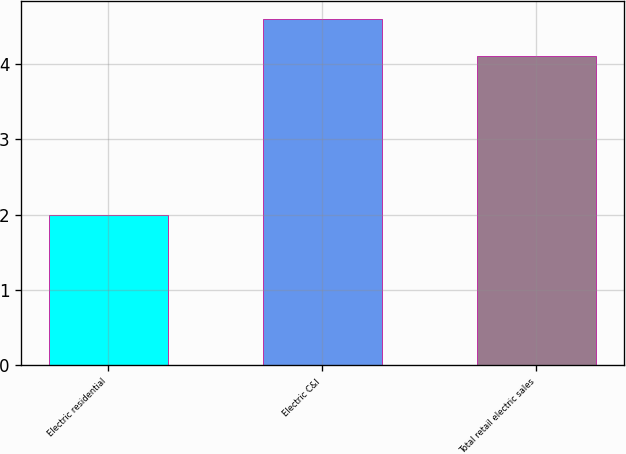Convert chart. <chart><loc_0><loc_0><loc_500><loc_500><bar_chart><fcel>Electric residential<fcel>Electric C&I<fcel>Total retail electric sales<nl><fcel>2<fcel>4.6<fcel>4.1<nl></chart> 